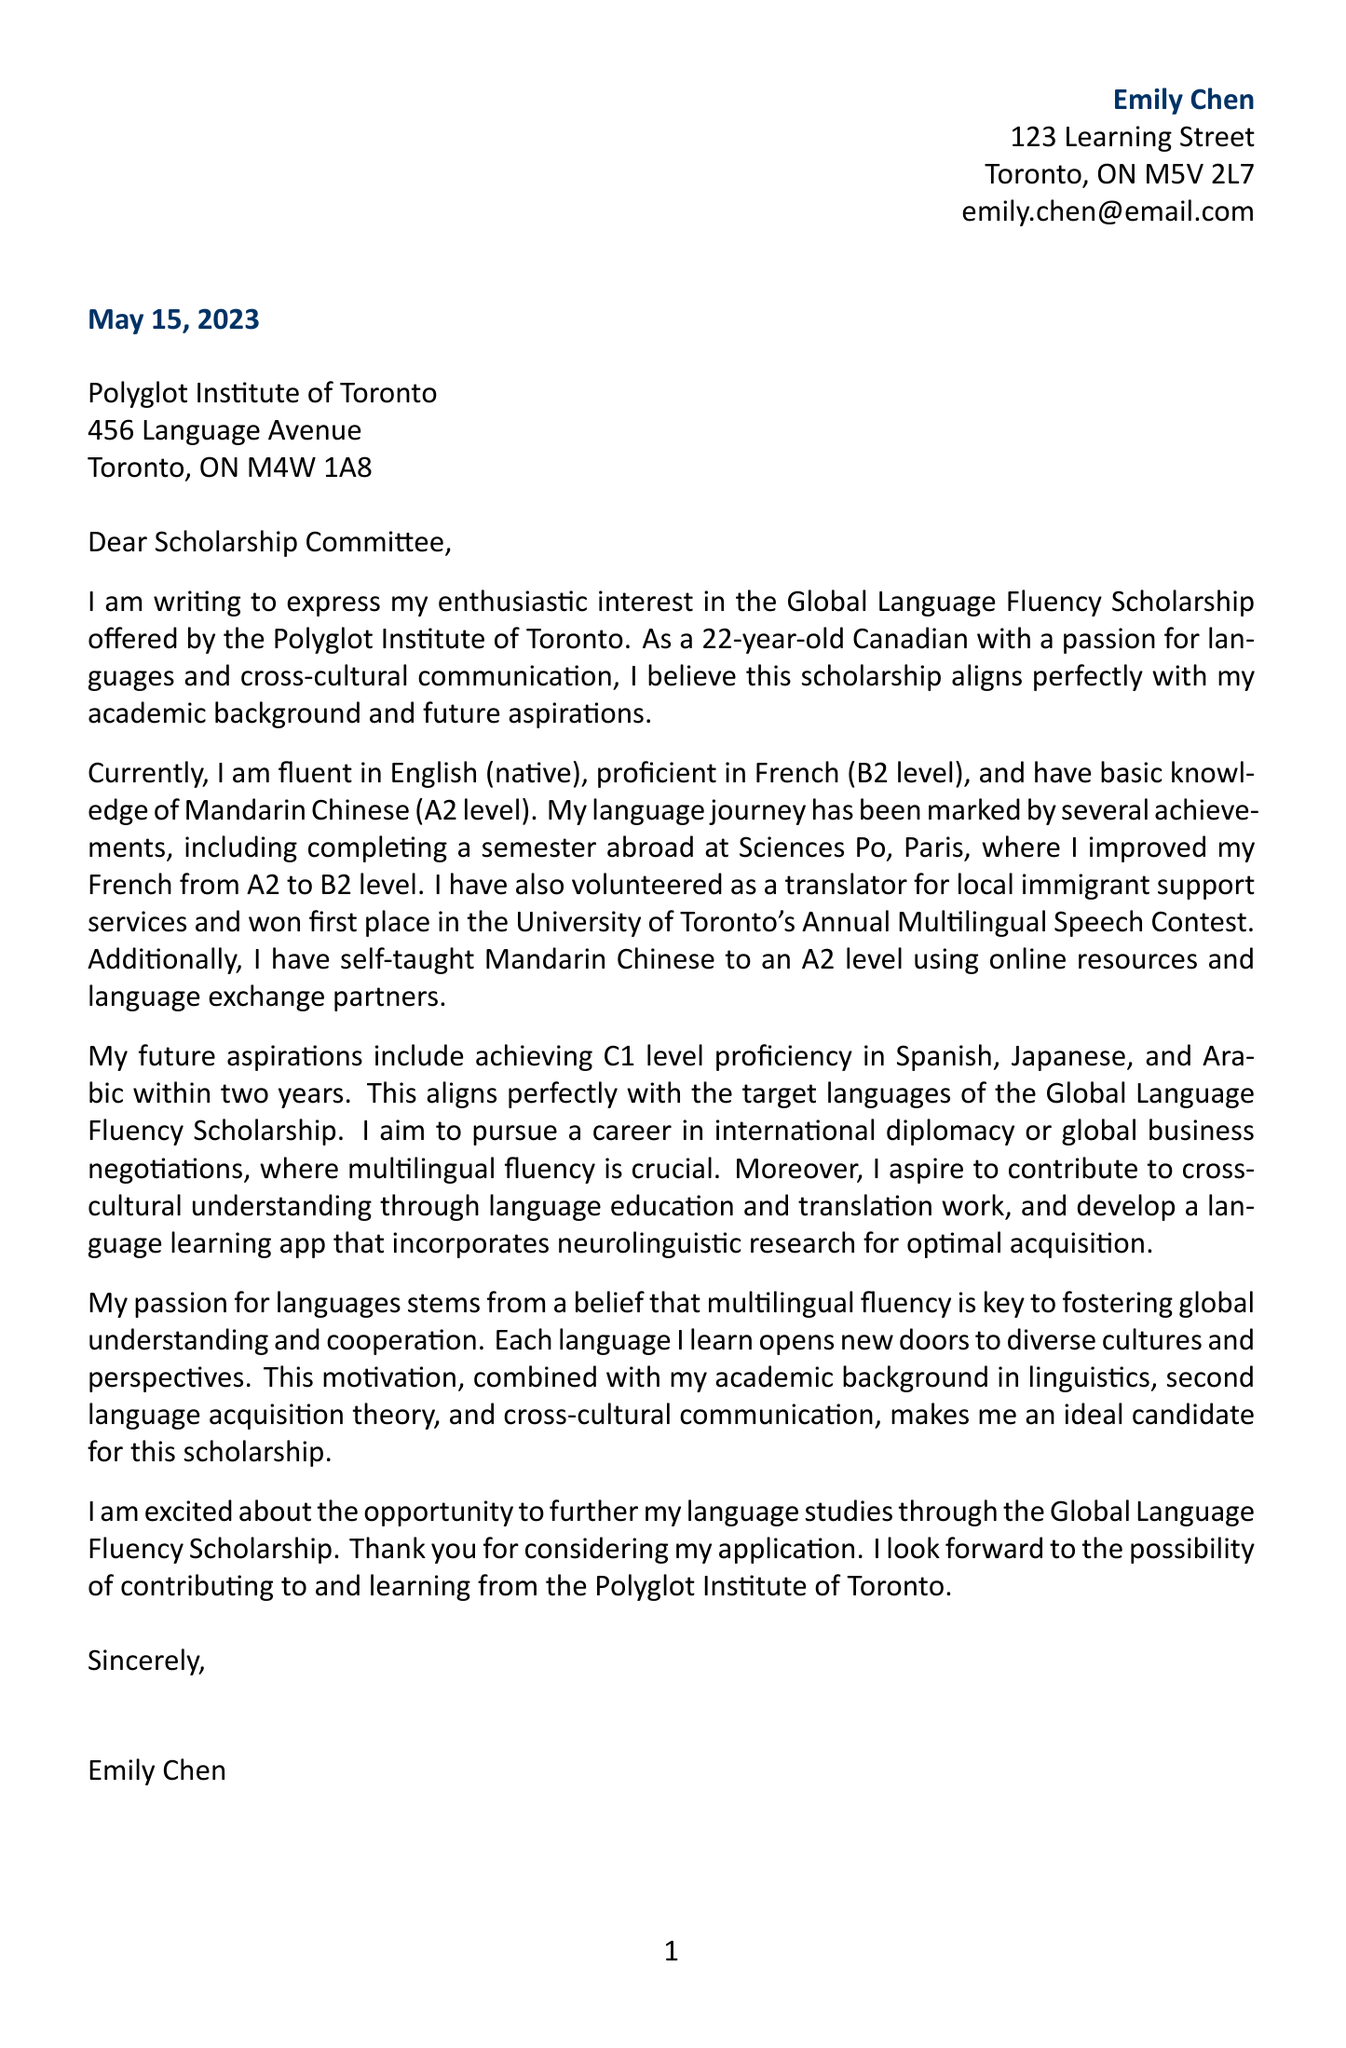What is the name of the applicant? The name of the applicant is stated in the letter's header as "Emily Chen."
Answer: Emily Chen What is the age of the applicant? The applicant's age is mentioned in the introduction of the letter.
Answer: 22 What scholarship is Emily applying for? The name of the scholarship is explicitly mentioned in the beginning of the letter.
Answer: Global Language Fluency Scholarship Which organization offers the scholarship? The organization offering the scholarship is indicated in the letter.
Answer: Polyglot Institute of Toronto What is Emily's current level of proficiency in Mandarin? The document specifies her proficiency levels under current language proficiency.
Answer: A2 What achievement did Emily accomplish at Sciences Po, Paris? The document states that she improved her French level during her semester abroad.
Answer: Improved French from A2 to B2 level How many target languages does the scholarship focus on? The number of target languages is specified in the scholarship details section.
Answer: Three What is Emily's future aspiration related to her career? The letter outlines her future career goal in the body paragraph.
Answer: International diplomacy or global business negotiations What is one of Emily's motivations for pursuing multilingual fluency? The motivation for learning languages is explained in the motivation statement.
Answer: Fostering global understanding and cooperation 